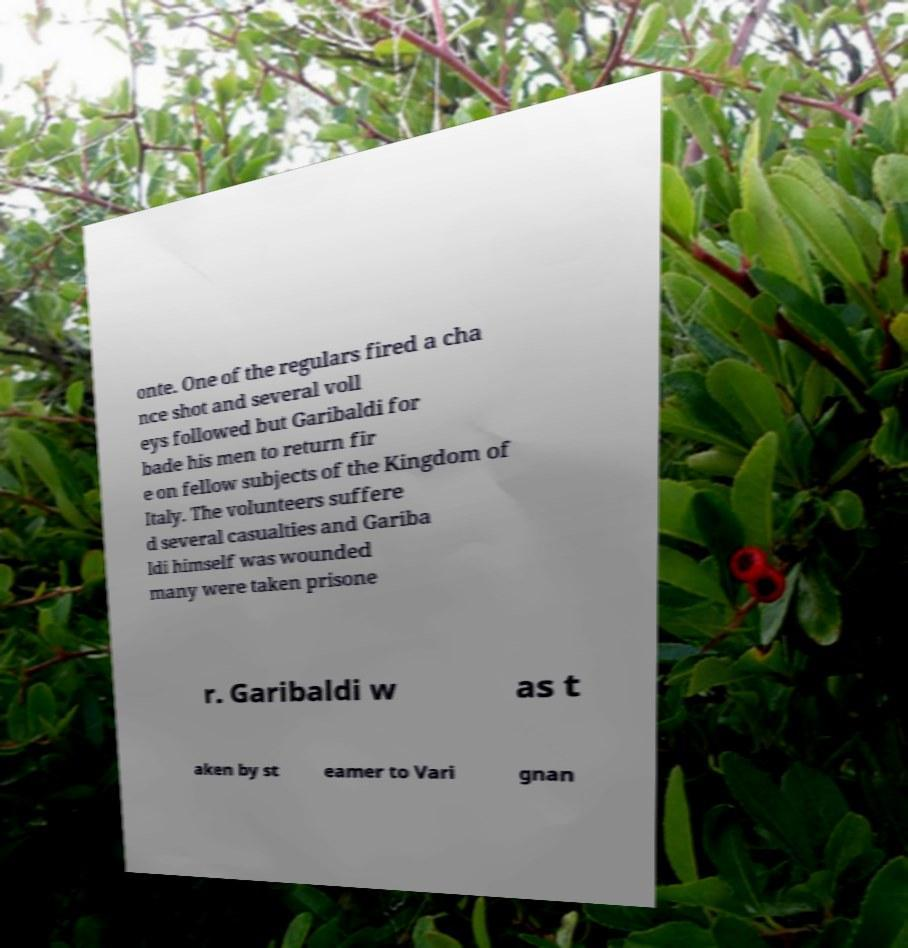Please identify and transcribe the text found in this image. onte. One of the regulars fired a cha nce shot and several voll eys followed but Garibaldi for bade his men to return fir e on fellow subjects of the Kingdom of Italy. The volunteers suffere d several casualties and Gariba ldi himself was wounded many were taken prisone r. Garibaldi w as t aken by st eamer to Vari gnan 